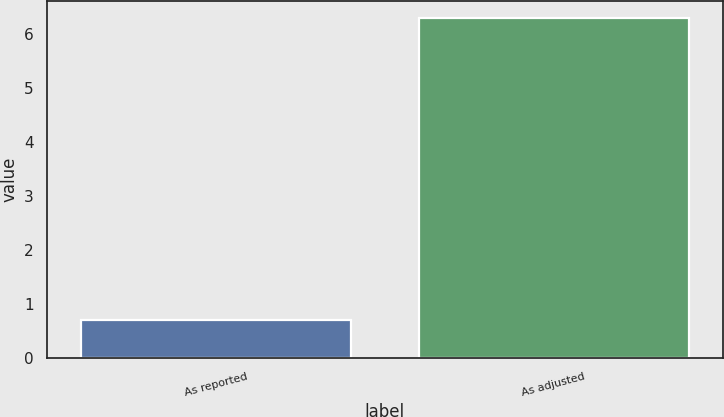Convert chart to OTSL. <chart><loc_0><loc_0><loc_500><loc_500><bar_chart><fcel>As reported<fcel>As adjusted<nl><fcel>0.7<fcel>6.3<nl></chart> 